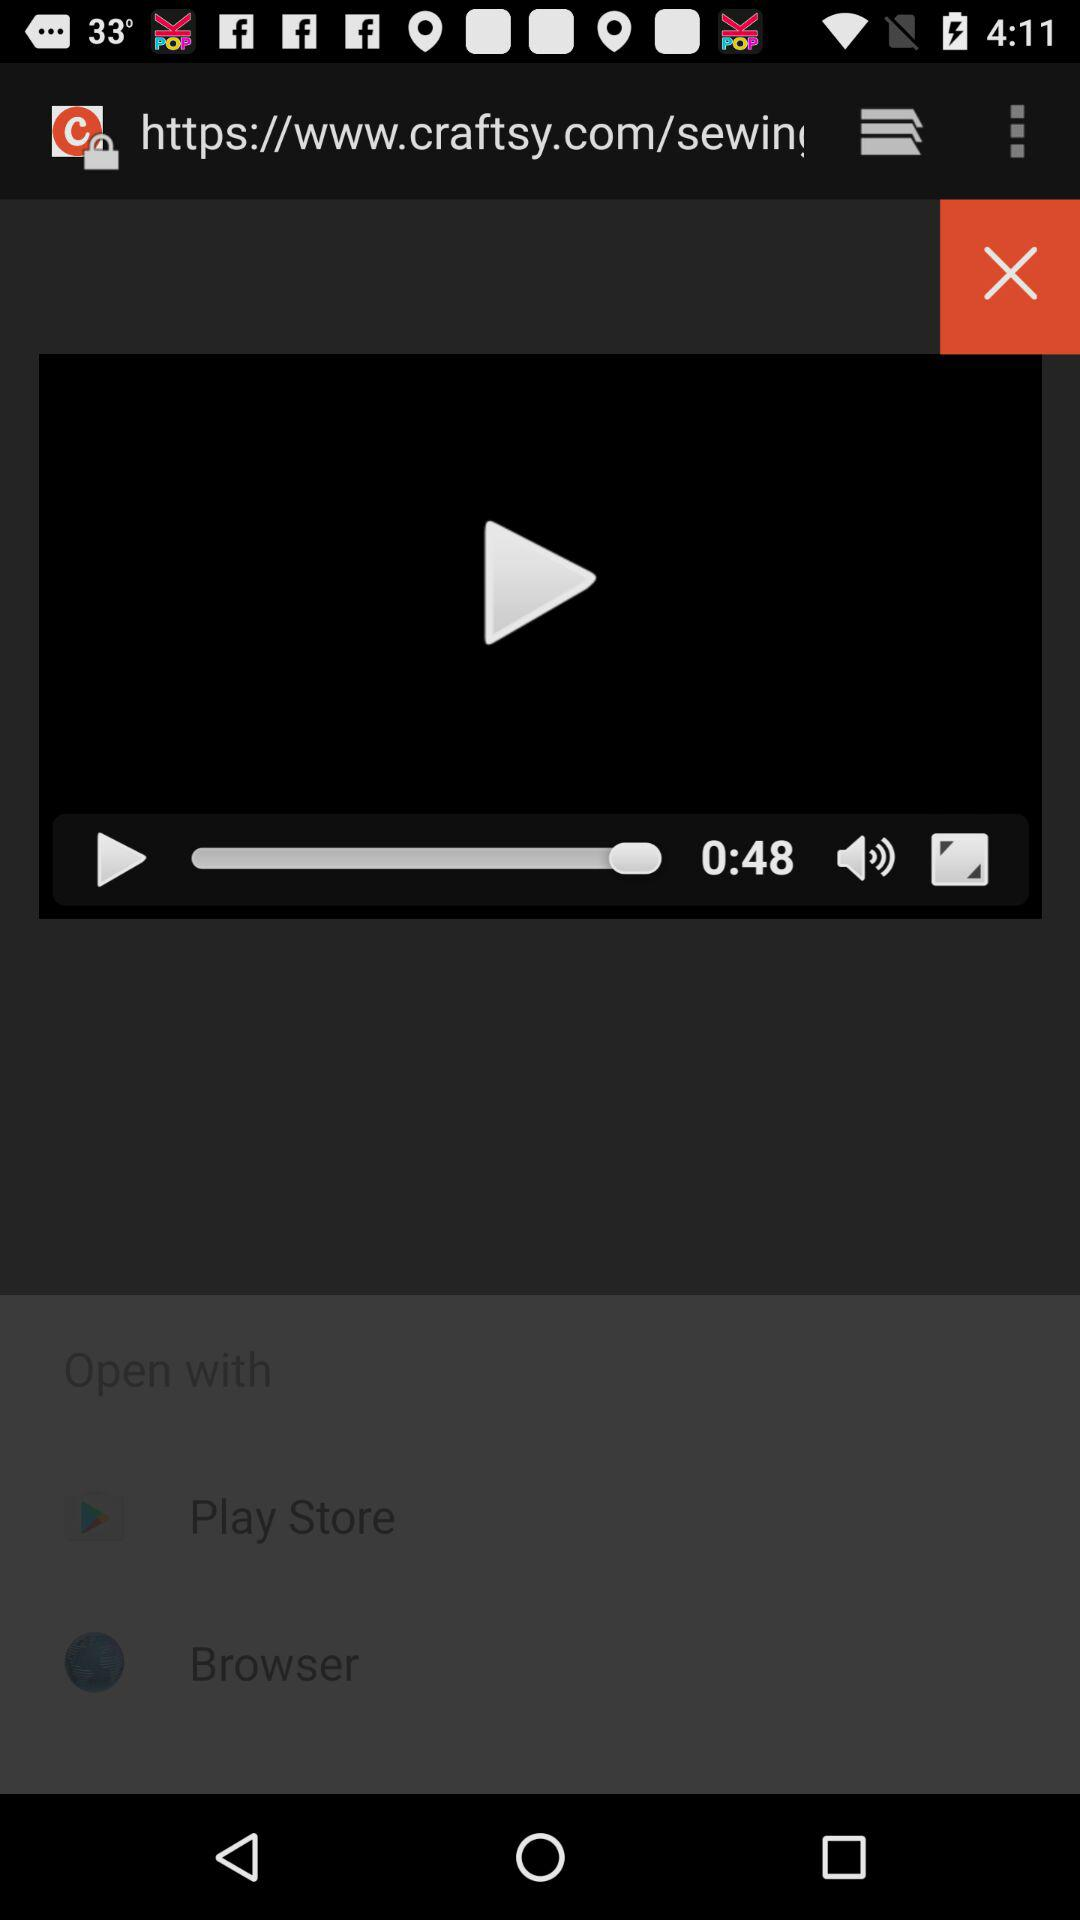What is the time duration of the video? The duration of the video is 0:48. 